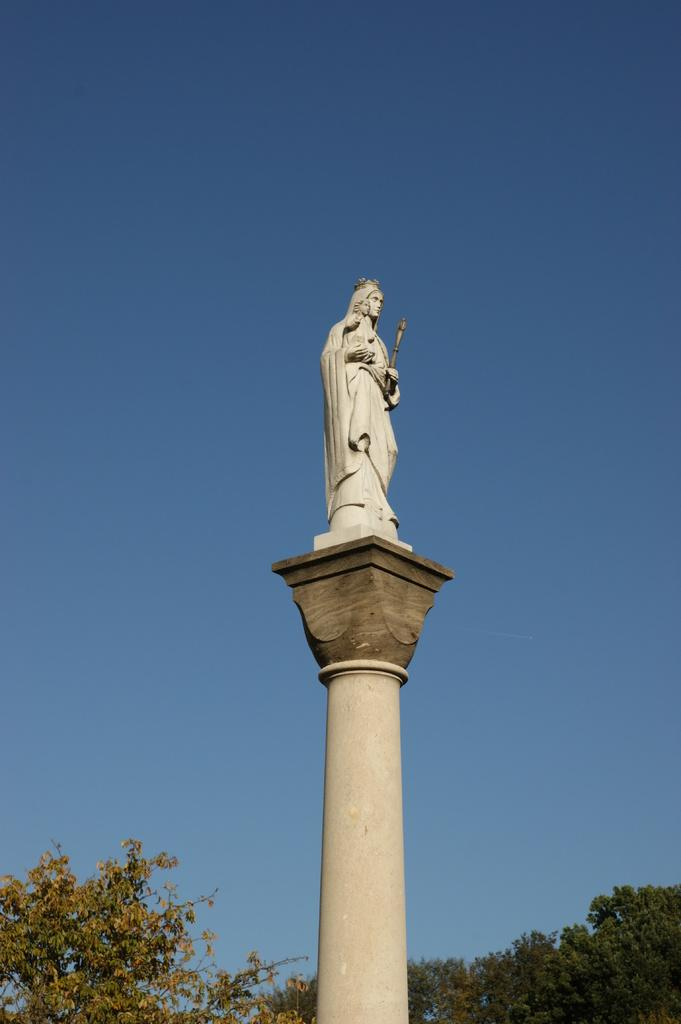What is the main subject in the center of the image? There is a sculpture in the center of the image. What type of natural elements can be seen at the bottom of the image? There are trees at the bottom of the image. What is visible in the background of the image? The sky is visible in the background of the image. What type of can is shown being used by the sculpture in the image? There is no can present in the image, as it features a sculpture, trees, and the sky. How many buns are visible on the sculpture in the image? There are no buns present on the sculpture in the image. 